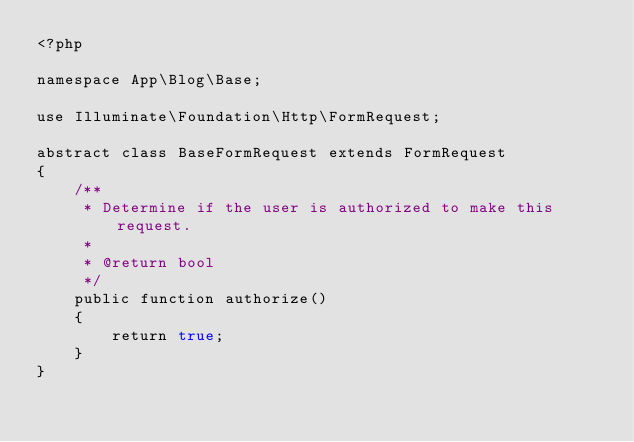Convert code to text. <code><loc_0><loc_0><loc_500><loc_500><_PHP_><?php

namespace App\Blog\Base;

use Illuminate\Foundation\Http\FormRequest;

abstract class BaseFormRequest extends FormRequest
{
    /**
     * Determine if the user is authorized to make this request.
     *
     * @return bool
     */
    public function authorize()
    {
        return true;
    }
}
</code> 